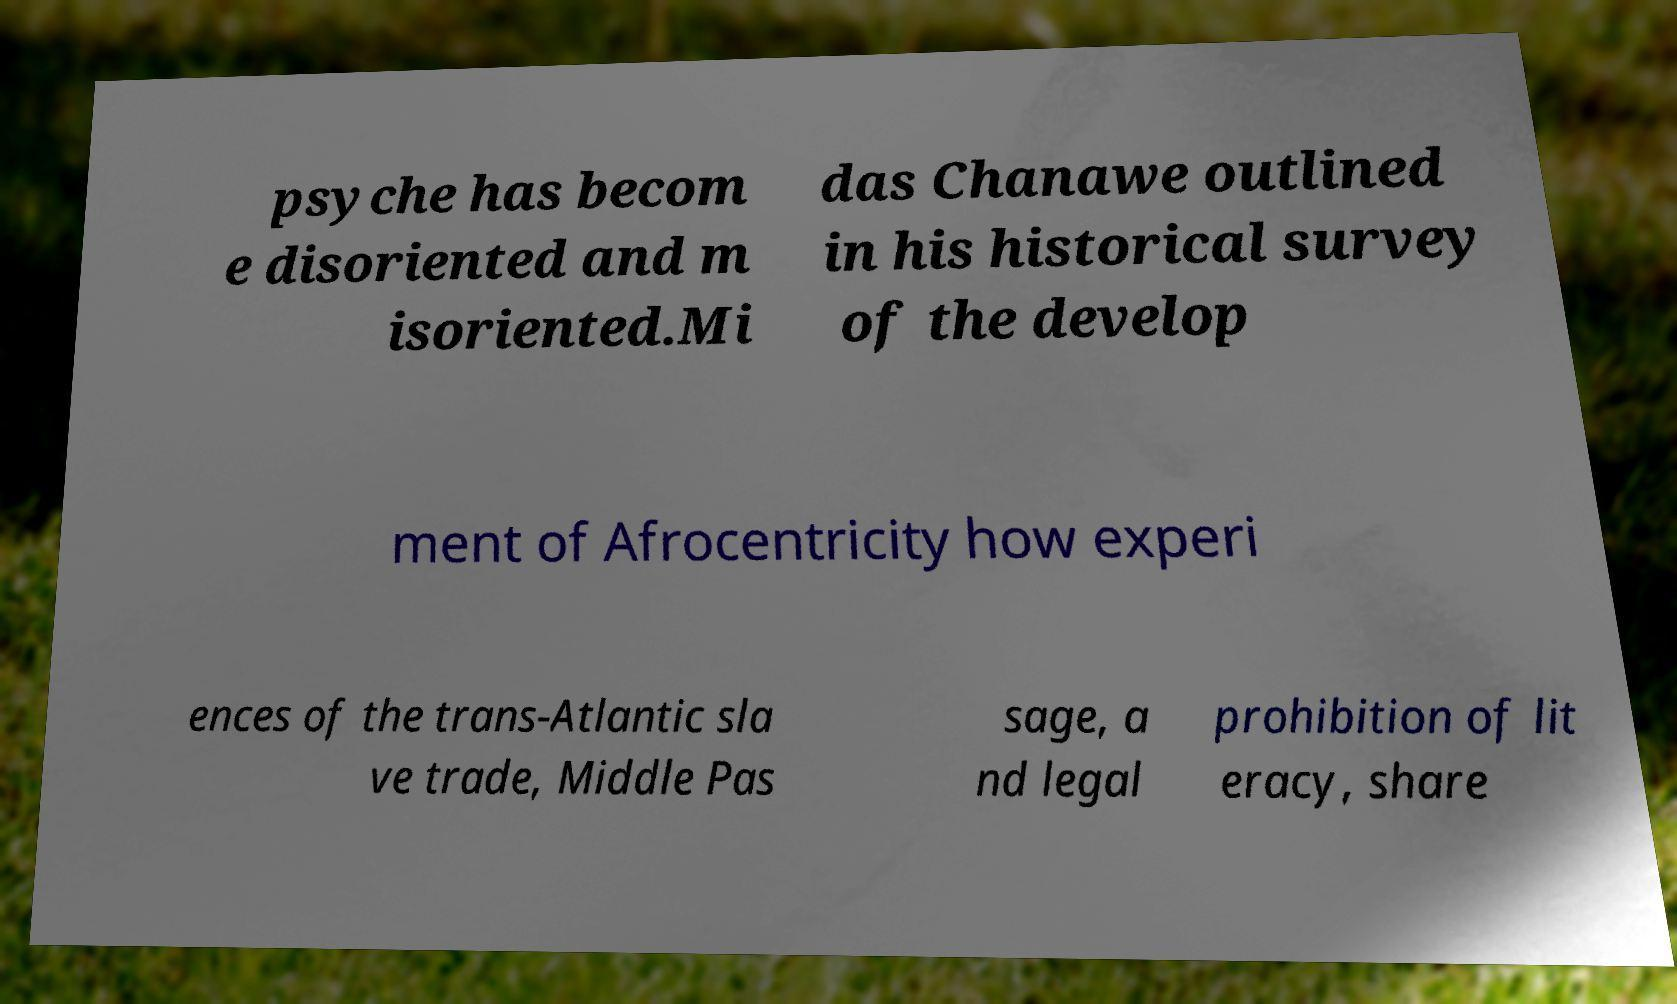What messages or text are displayed in this image? I need them in a readable, typed format. psyche has becom e disoriented and m isoriented.Mi das Chanawe outlined in his historical survey of the develop ment of Afrocentricity how experi ences of the trans-Atlantic sla ve trade, Middle Pas sage, a nd legal prohibition of lit eracy, share 